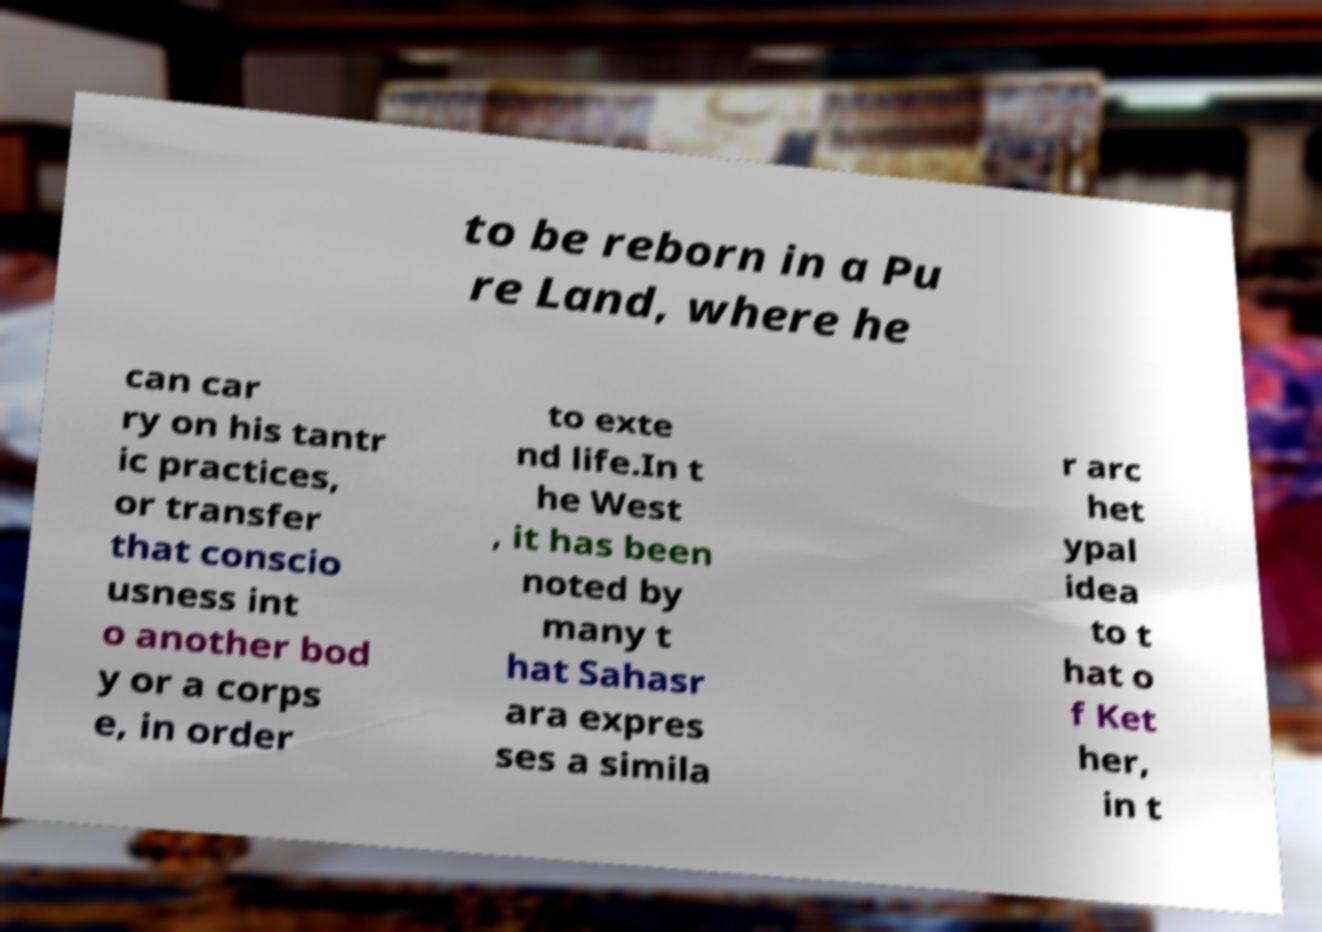Can you read and provide the text displayed in the image?This photo seems to have some interesting text. Can you extract and type it out for me? to be reborn in a Pu re Land, where he can car ry on his tantr ic practices, or transfer that conscio usness int o another bod y or a corps e, in order to exte nd life.In t he West , it has been noted by many t hat Sahasr ara expres ses a simila r arc het ypal idea to t hat o f Ket her, in t 